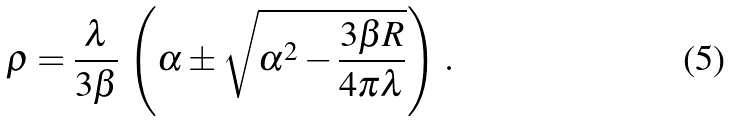<formula> <loc_0><loc_0><loc_500><loc_500>\rho = \frac { \lambda } { 3 \beta } \, \left ( \alpha \pm \sqrt { \alpha ^ { 2 } - \frac { 3 \beta R } { 4 \pi \lambda } } \right ) \, .</formula> 